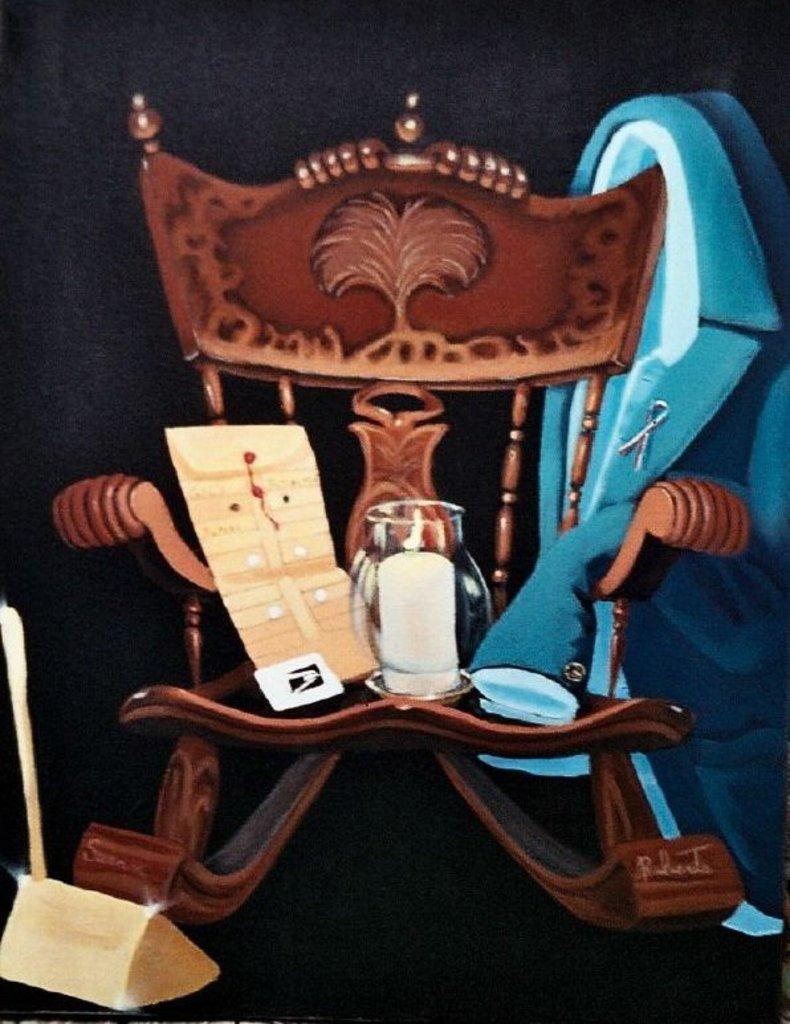In one or two sentences, can you explain what this image depicts? It is an edited image, in this image there a is chair, in that chair there is a bottle, book and a coat, on the left side there is an object. 